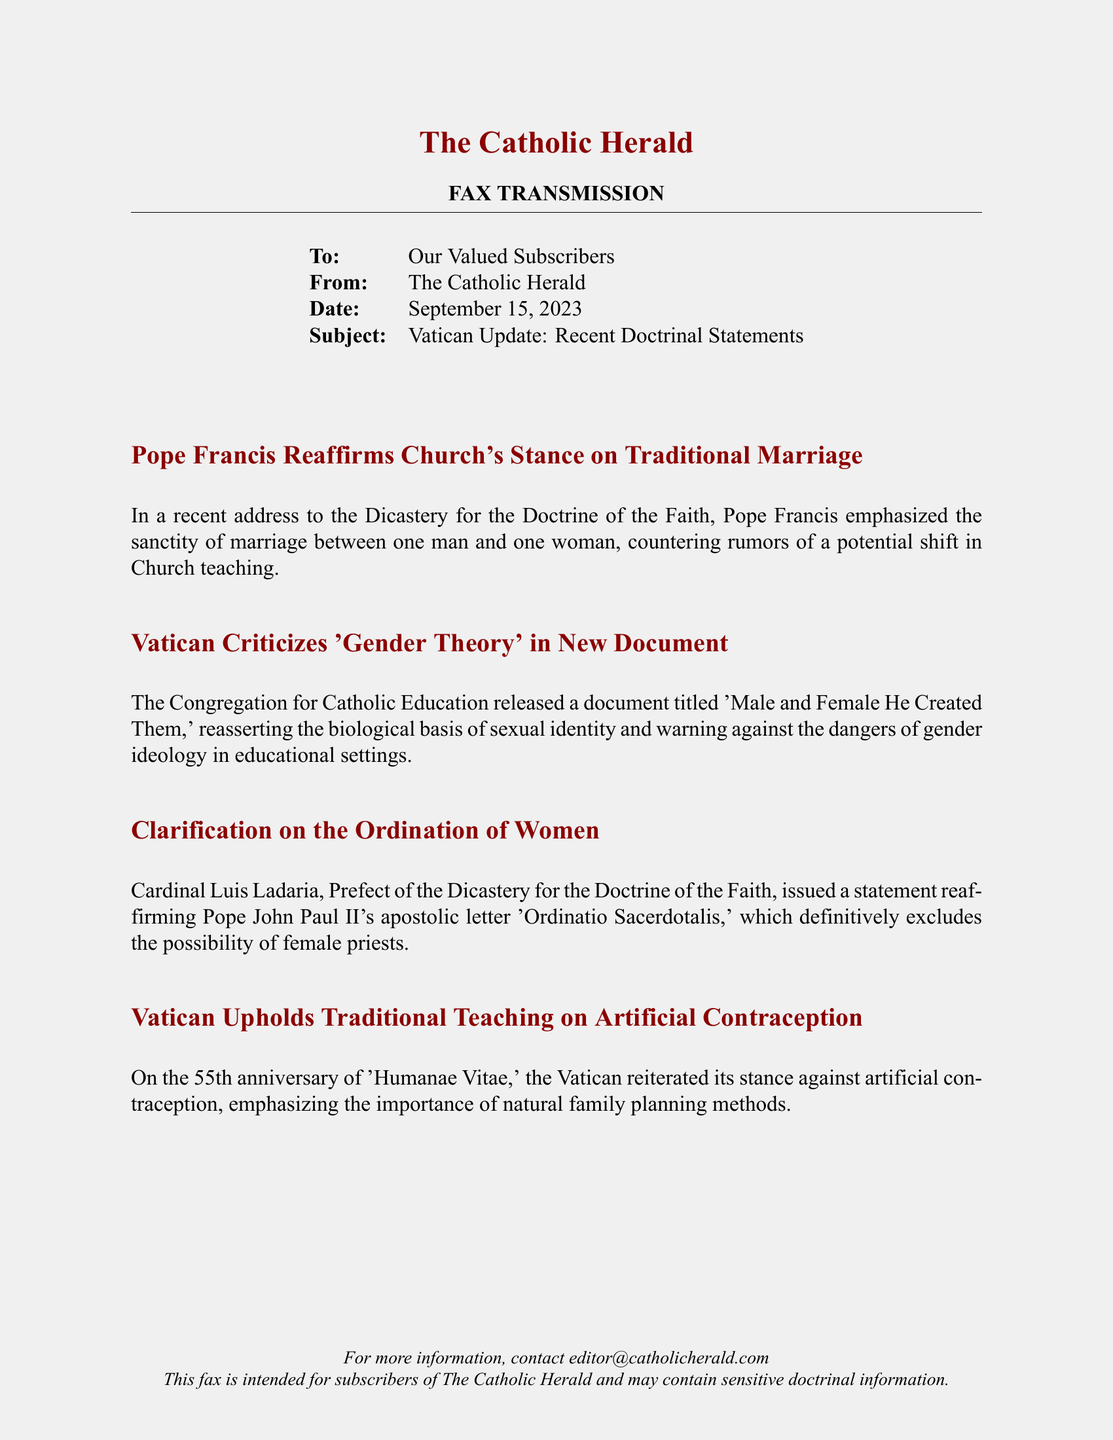What is the date of the fax? The date of the fax is explicitly stated in the header section of the document.
Answer: September 15, 2023 Who issued a statement about the ordination of women? The statement regarding the ordination of women was issued by Cardinal Luis Ladaria, whose title is also mentioned in the document.
Answer: Cardinal Luis Ladaria What document does the Vatican criticize regarding gender theory? The document that criticizes gender theory is titled 'Male and Female He Created Them', as noted in the document.
Answer: 'Male and Female He Created Them' What is the Church's stance on marriage as reaffirmed by Pope Francis? The fax specifies the Church's stance on marriage as being between one man and one woman.
Answer: One man and one woman What anniversary is mentioned regarding 'Humanae Vitae'? The document mentions the 55th anniversary of 'Humanae Vitae' in relation to the reaffirmation of the teaching on artificial contraception.
Answer: 55th Which Pope's apostolic letter is referenced regarding the ordination of women? The apostolic letter referenced is by Pope John Paul II, as stated in the document.
Answer: Pope John Paul II What does the Vatican emphasize regarding family planning? The Vatican emphasizes the importance of natural family planning methods, as mentioned in the document.
Answer: Natural family planning methods 